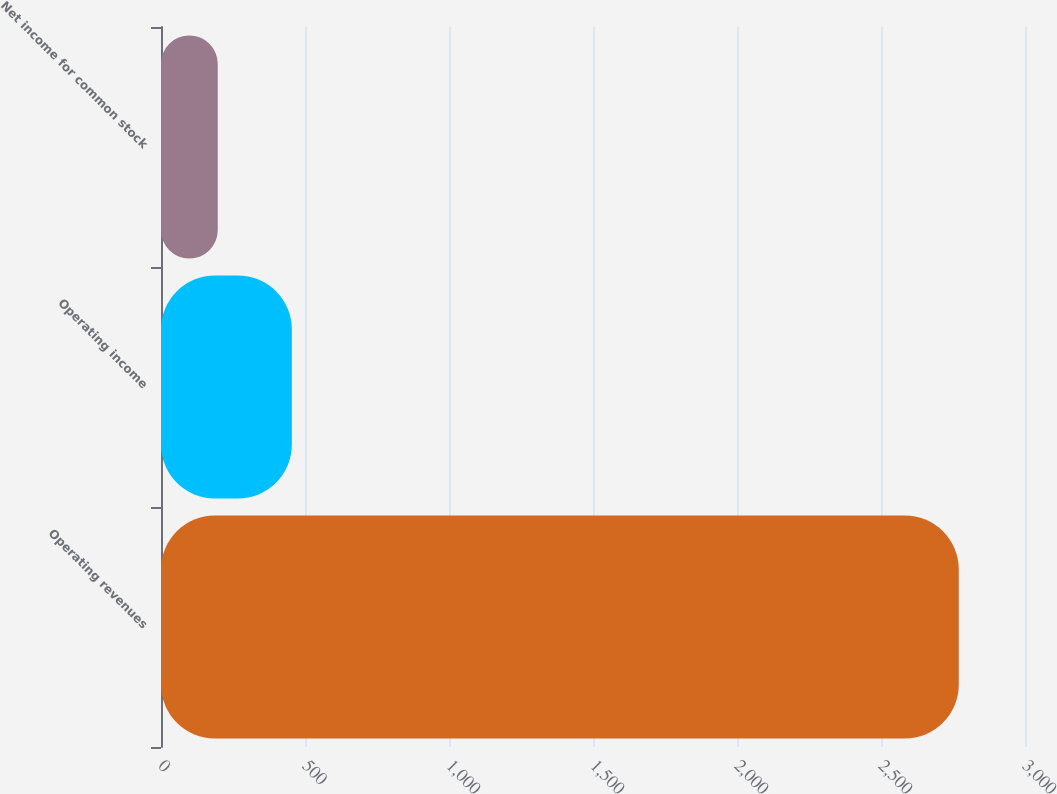Convert chart. <chart><loc_0><loc_0><loc_500><loc_500><bar_chart><fcel>Operating revenues<fcel>Operating income<fcel>Net income for common stock<nl><fcel>2770<fcel>454.3<fcel>197<nl></chart> 